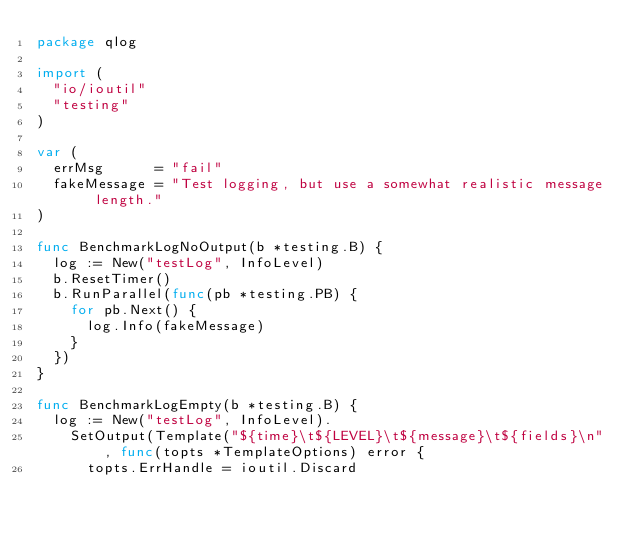Convert code to text. <code><loc_0><loc_0><loc_500><loc_500><_Go_>package qlog

import (
	"io/ioutil"
	"testing"
)

var (
	errMsg      = "fail"
	fakeMessage = "Test logging, but use a somewhat realistic message length."
)

func BenchmarkLogNoOutput(b *testing.B) {
	log := New("testLog", InfoLevel)
	b.ResetTimer()
	b.RunParallel(func(pb *testing.PB) {
		for pb.Next() {
			log.Info(fakeMessage)
		}
	})
}

func BenchmarkLogEmpty(b *testing.B) {
	log := New("testLog", InfoLevel).
		SetOutput(Template("${time}\t${LEVEL}\t${message}\t${fields}\n", func(topts *TemplateOptions) error {
			topts.ErrHandle = ioutil.Discard</code> 